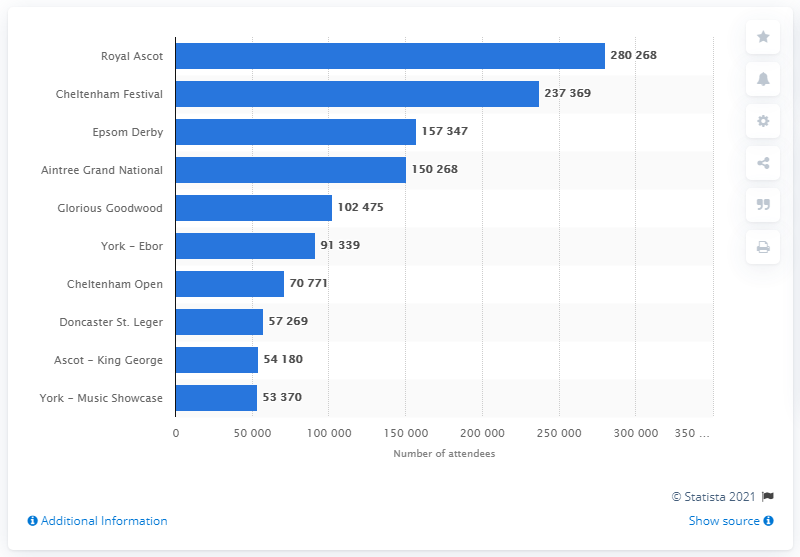Mention a couple of crucial points in this snapshot. In 2012, the Royal Ascot meeting was attended by a total of 280,268 people. 